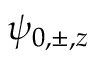Convert formula to latex. <formula><loc_0><loc_0><loc_500><loc_500>\psi _ { 0 , \pm , z }</formula> 